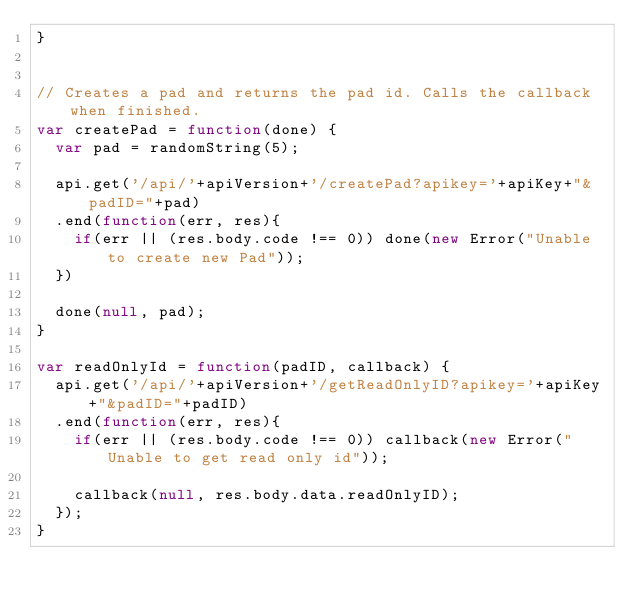Convert code to text. <code><loc_0><loc_0><loc_500><loc_500><_JavaScript_>}


// Creates a pad and returns the pad id. Calls the callback when finished.
var createPad = function(done) {
  var pad = randomString(5);

  api.get('/api/'+apiVersion+'/createPad?apikey='+apiKey+"&padID="+pad)
  .end(function(err, res){
    if(err || (res.body.code !== 0)) done(new Error("Unable to create new Pad"));
  })

  done(null, pad);
}

var readOnlyId = function(padID, callback) {
  api.get('/api/'+apiVersion+'/getReadOnlyID?apikey='+apiKey+"&padID="+padID)
  .end(function(err, res){
    if(err || (res.body.code !== 0)) callback(new Error("Unable to get read only id"));

    callback(null, res.body.data.readOnlyID);
  });
}
</code> 